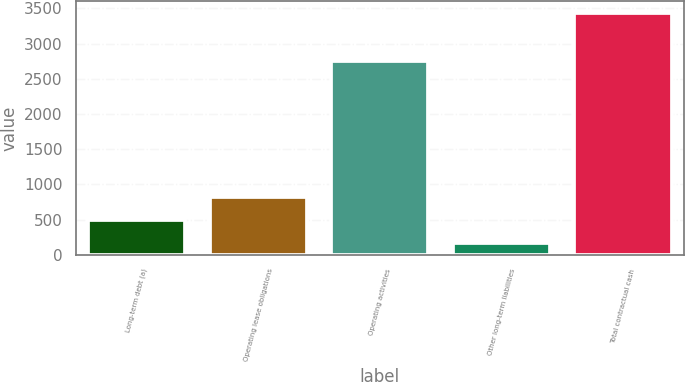Convert chart. <chart><loc_0><loc_0><loc_500><loc_500><bar_chart><fcel>Long-term debt (a)<fcel>Operating lease obligations<fcel>Operating activities<fcel>Other long-term liabilities<fcel>Total contractual cash<nl><fcel>495.2<fcel>821.4<fcel>2752<fcel>169<fcel>3431<nl></chart> 